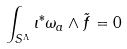<formula> <loc_0><loc_0><loc_500><loc_500>\int _ { S ^ { \Lambda } } \iota ^ { * } \omega _ { a } \wedge \tilde { f } = 0</formula> 